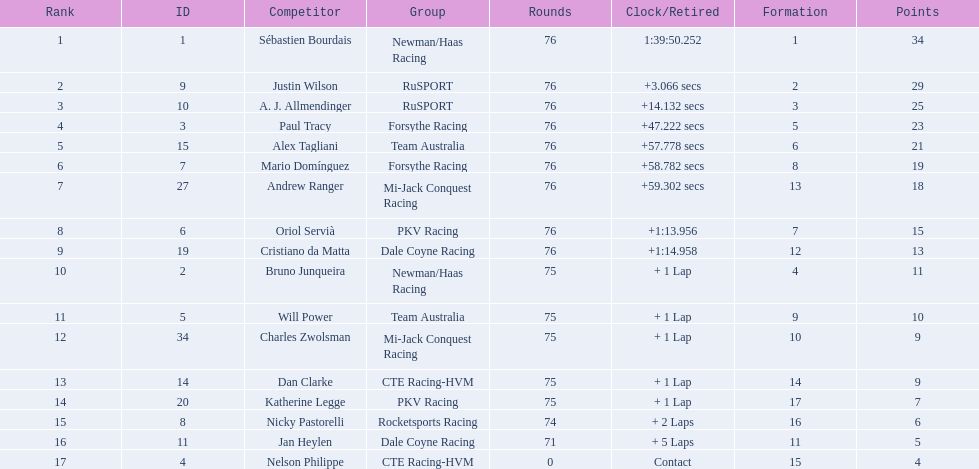Is there a driver named charles zwolsman? Charles Zwolsman. How many points did he acquire? 9. Were there any other entries that got the same number of points? 9. Who did that entry belong to? Dan Clarke. 